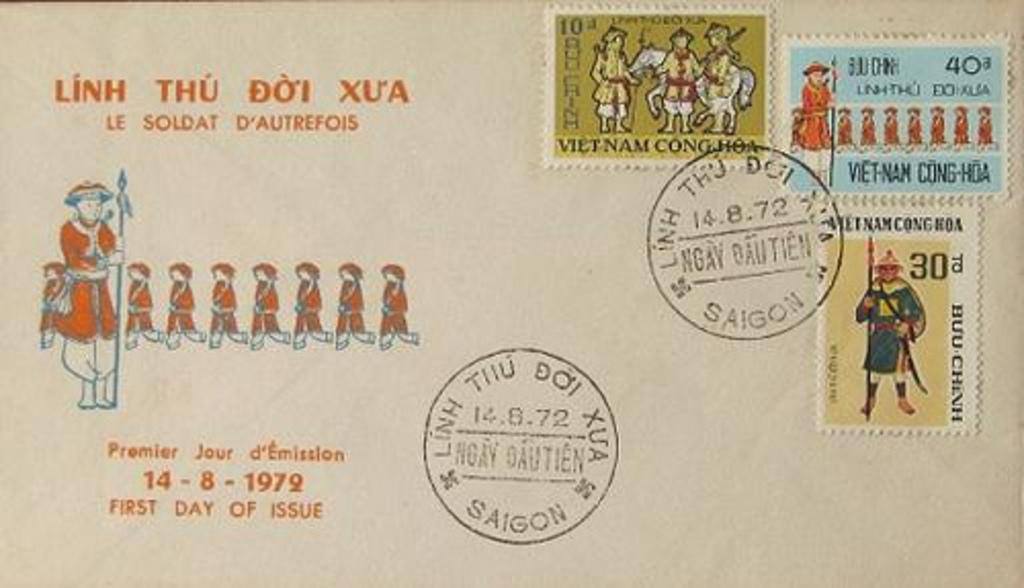What is the main subject of the image? The image resembles an envelope. What can be seen on the envelope? There is a group of people depicted on the envelope. Is there any additional marking on the envelope? Yes, there is a person's stamp on the envelope. What type of quilt is being used as a background for the amusement park in the image? There is no quilt or amusement park present in the image; it is an envelope with a group of people depicted on it. What substance is being used to create the illusion of a person's stamp on the envelope? There is no mention of a substance being used to create the illusion of a person's stamp on the envelope; it is a real stamp. 